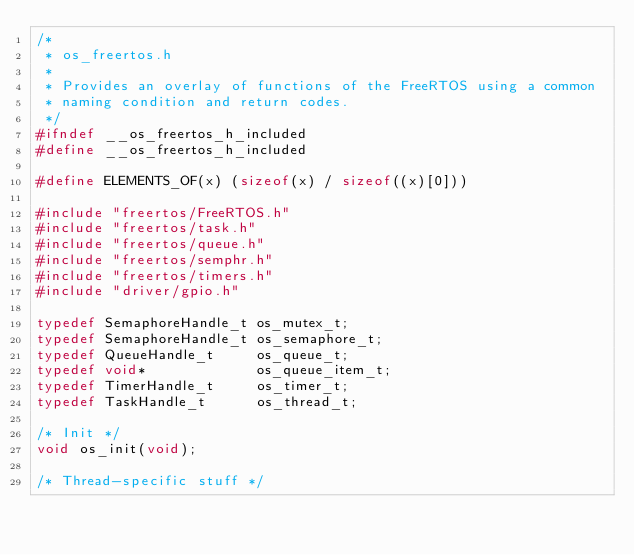Convert code to text. <code><loc_0><loc_0><loc_500><loc_500><_C_>/*
 * os_freertos.h
 *
 * Provides an overlay of functions of the FreeRTOS using a common
 * naming condition and return codes.
 */
#ifndef __os_freertos_h_included
#define __os_freertos_h_included

#define ELEMENTS_OF(x) (sizeof(x) / sizeof((x)[0]))

#include "freertos/FreeRTOS.h"
#include "freertos/task.h"
#include "freertos/queue.h"
#include "freertos/semphr.h"
#include "freertos/timers.h"
#include "driver/gpio.h"

typedef SemaphoreHandle_t os_mutex_t;
typedef SemaphoreHandle_t os_semaphore_t;
typedef QueueHandle_t     os_queue_t;
typedef void*             os_queue_item_t;
typedef TimerHandle_t     os_timer_t;
typedef TaskHandle_t      os_thread_t;

/* Init */
void os_init(void);

/* Thread-specific stuff */</code> 